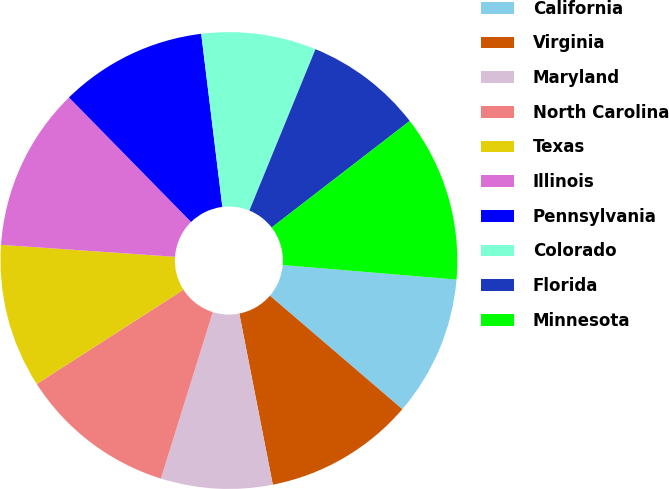Convert chart. <chart><loc_0><loc_0><loc_500><loc_500><pie_chart><fcel>California<fcel>Virginia<fcel>Maryland<fcel>North Carolina<fcel>Texas<fcel>Illinois<fcel>Pennsylvania<fcel>Colorado<fcel>Florida<fcel>Minnesota<nl><fcel>9.95%<fcel>10.64%<fcel>7.89%<fcel>11.1%<fcel>10.18%<fcel>11.56%<fcel>10.41%<fcel>8.12%<fcel>8.35%<fcel>11.79%<nl></chart> 